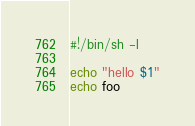Convert code to text. <code><loc_0><loc_0><loc_500><loc_500><_Bash_>#!/bin/sh -l

echo "hello $1"
echo foo
</code> 